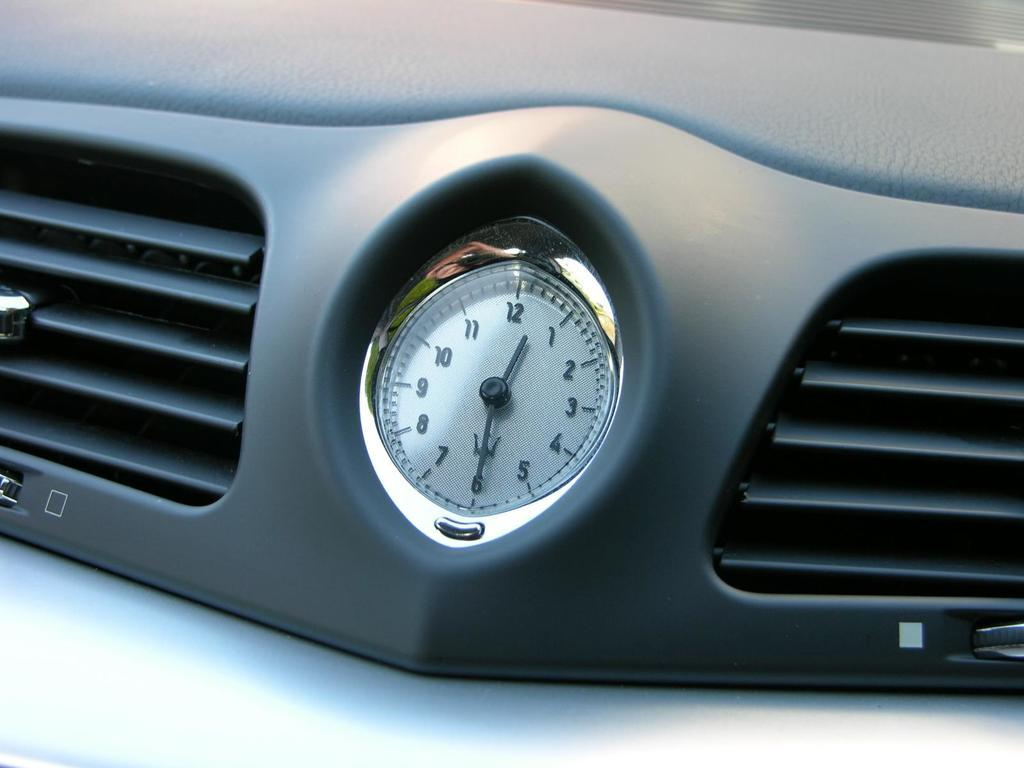What object is present on the black surface in the image? There is a clock on a black surface in the image. What other objects can be seen on the black surface? AC grills are also present on the black surface. What is the color of the surface above the AC grills? There is a black surface at the top of the AC grills. What type of hydrant is visible in the image? There is no hydrant present in the image. How can the clock be adjusted for accuracy in the image? The image does not show any way to adjust the clock for accuracy, as it is a static representation. 